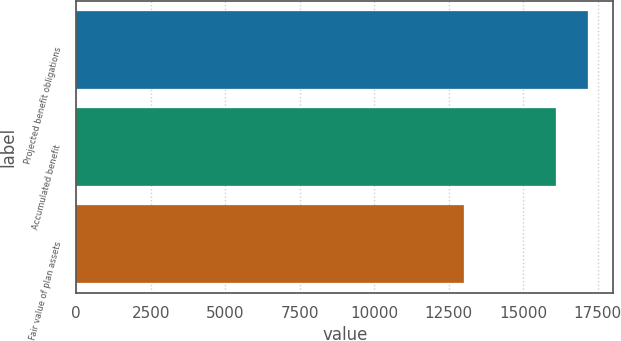Convert chart. <chart><loc_0><loc_0><loc_500><loc_500><bar_chart><fcel>Projected benefit obligations<fcel>Accumulated benefit<fcel>Fair value of plan assets<nl><fcel>17159<fcel>16102<fcel>12999<nl></chart> 